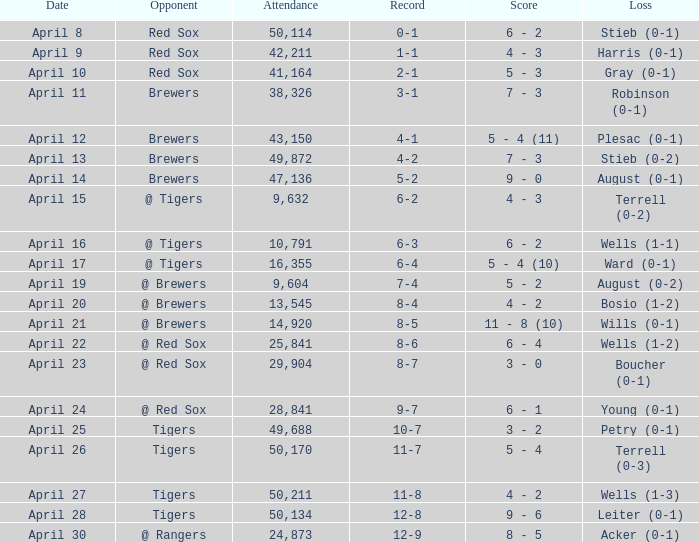Among opponents, who has an 11-8 win-loss record and an attendance of over 29,904? Tigers. 